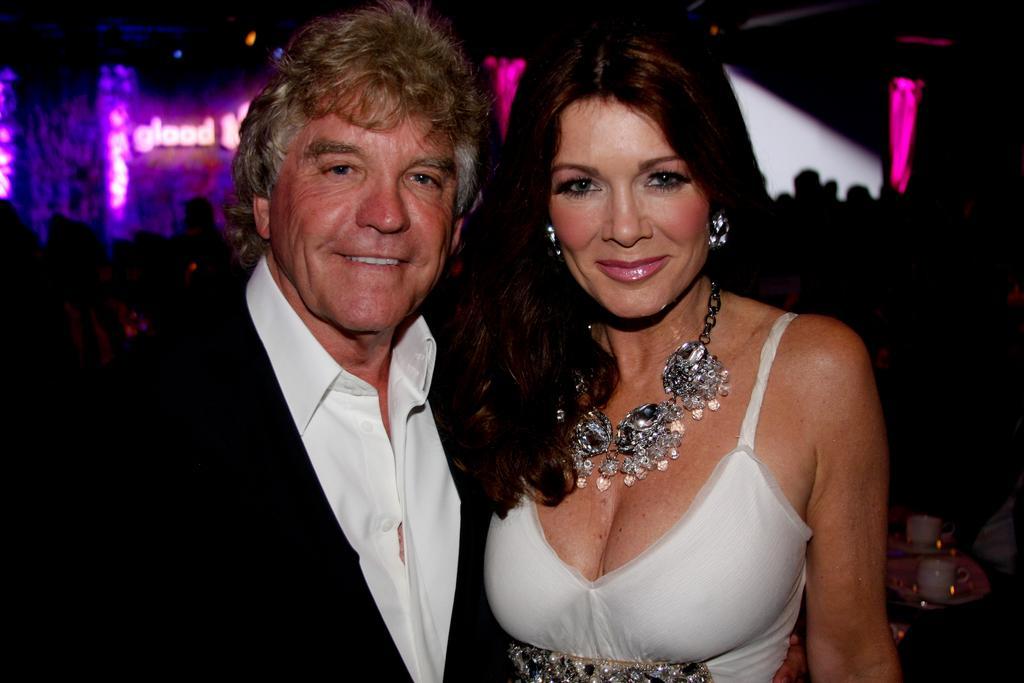Please provide a concise description of this image. In this image we can see a man and a woman standing. On the backside we can see some cups in the plates, a group of people standing, some lights and text on a wall. 